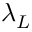<formula> <loc_0><loc_0><loc_500><loc_500>\lambda _ { L }</formula> 